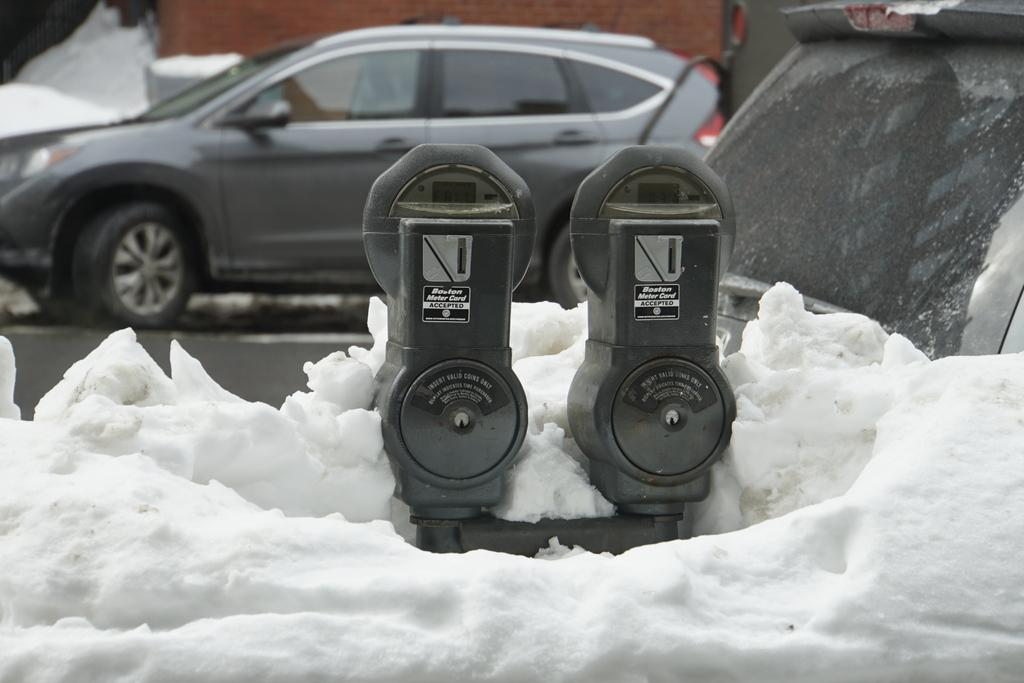Provide a one-sentence caption for the provided image. A picture of two parking meters that read "insert coins here.". 